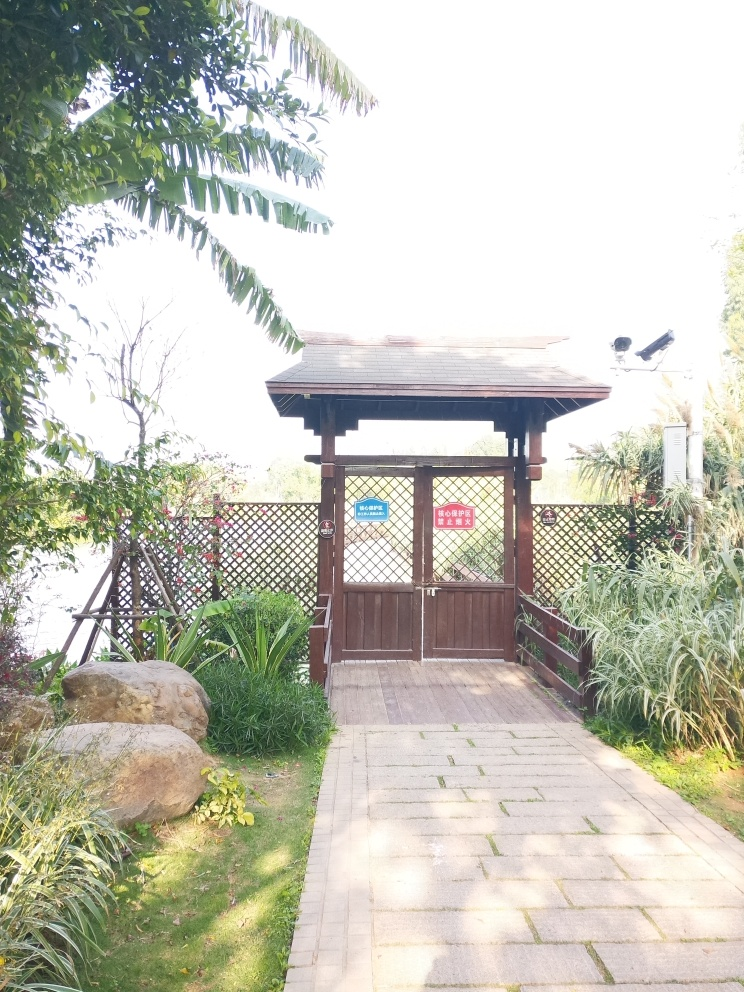How would you rate the overall quality of the image?
A. Acceptable
B. Terrible
C. Perfect While the structure featured in the image, a small garden pavilion, is charming, the picture's quality suffers due to overexposure and lack of balance in lighting. The top portion of the image is significantly brighter compared to the rest, which hampers the visibility of some details. Therefore, considering composition, exposure, and clarity, I'd rate the image as 'Acceptable,' given that it is not without merit but has clear areas for improvement. 